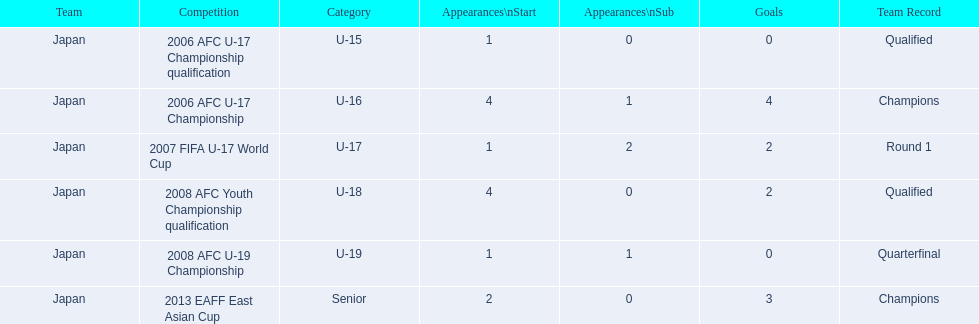What is the count of appearances for every competition? 1, 4, 1, 4, 1, 2. What is the goal count for each competition? 0, 4, 2, 2, 0, 3. In which competition(s) are the most appearances made? 2006 AFC U-17 Championship, 2008 AFC Youth Championship qualification. In which competition(s) are the most goals scored? 2006 AFC U-17 Championship. 